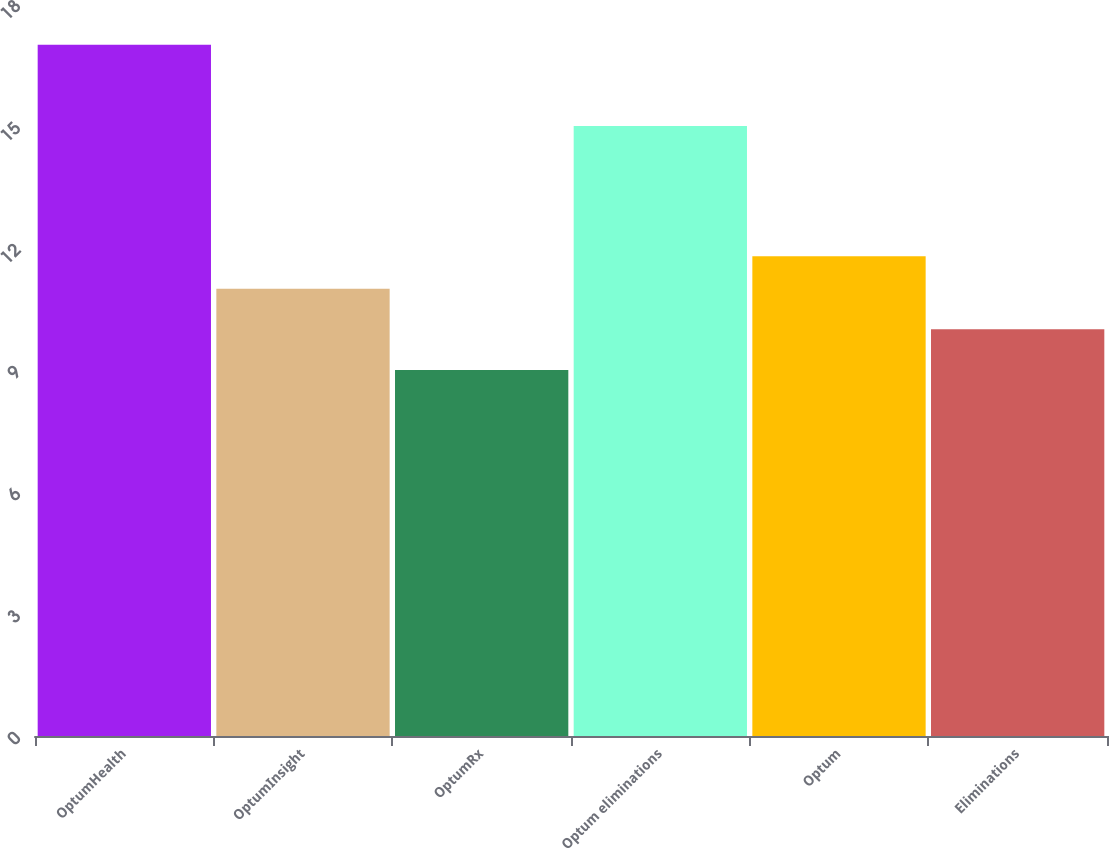Convert chart. <chart><loc_0><loc_0><loc_500><loc_500><bar_chart><fcel>OptumHealth<fcel>OptumInsight<fcel>OptumRx<fcel>Optum eliminations<fcel>Optum<fcel>Eliminations<nl><fcel>17<fcel>11<fcel>9<fcel>15<fcel>11.8<fcel>10<nl></chart> 